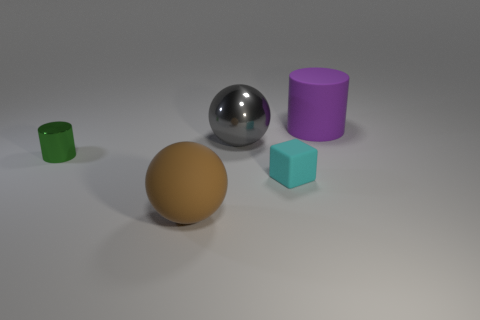Subtract all yellow cylinders. Subtract all brown balls. How many cylinders are left? 2 Add 2 cyan matte cubes. How many objects exist? 7 Subtract all blocks. How many objects are left? 4 Subtract all large brown spheres. Subtract all large brown rubber spheres. How many objects are left? 3 Add 2 matte cylinders. How many matte cylinders are left? 3 Add 4 large metal spheres. How many large metal spheres exist? 5 Subtract 0 cyan cylinders. How many objects are left? 5 